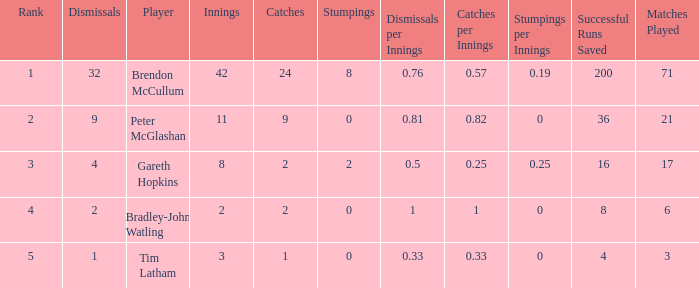List the ranks of all dismissals with a value of 4 3.0. 